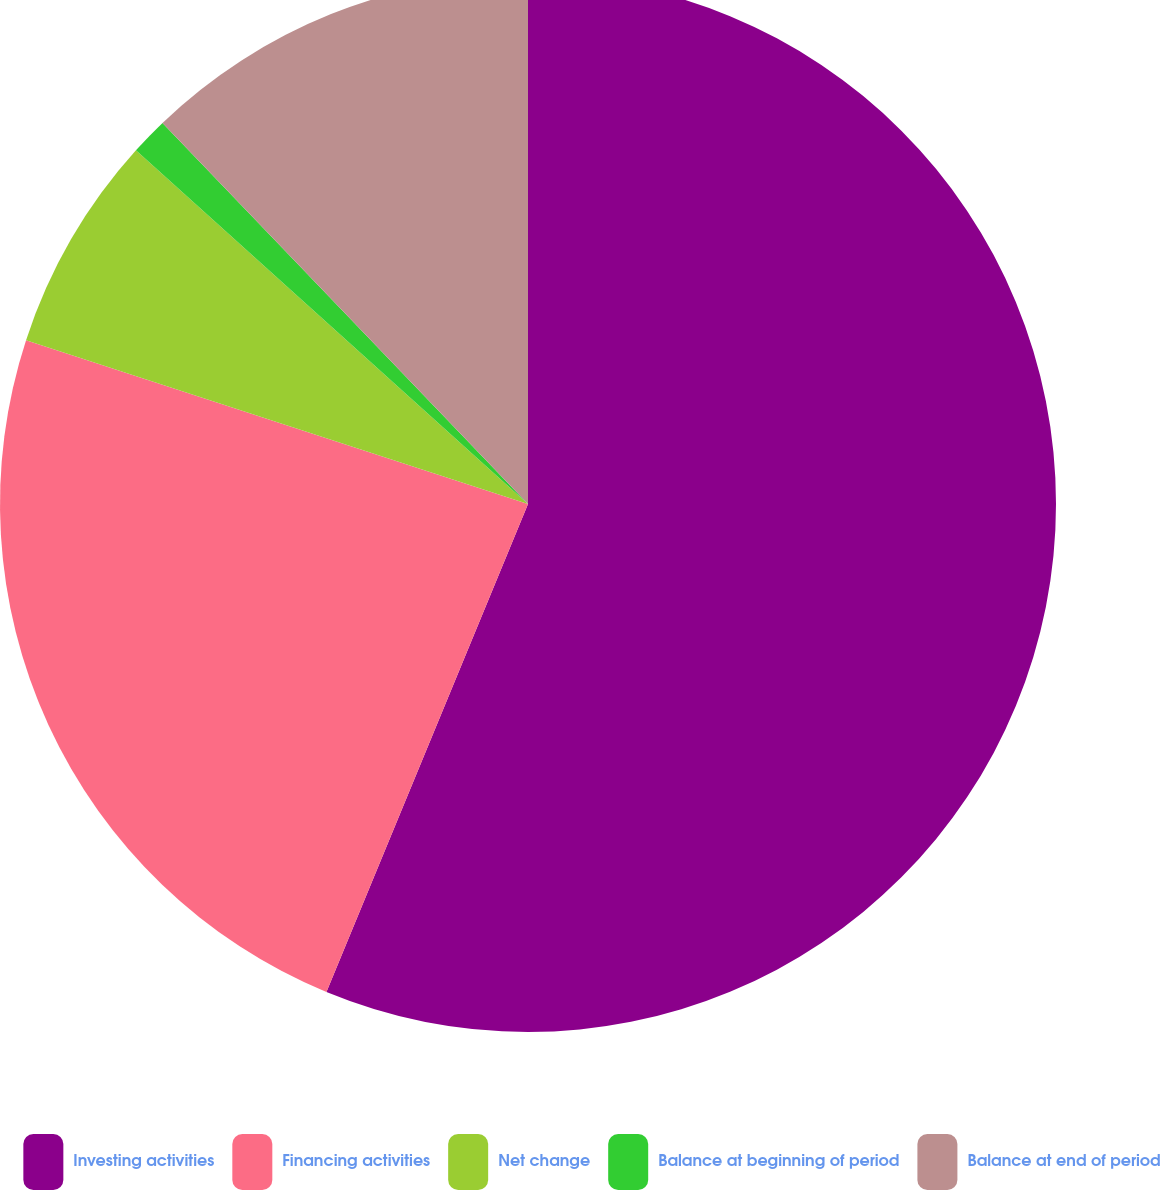Convert chart. <chart><loc_0><loc_0><loc_500><loc_500><pie_chart><fcel>Investing activities<fcel>Financing activities<fcel>Net change<fcel>Balance at beginning of period<fcel>Balance at end of period<nl><fcel>56.24%<fcel>23.79%<fcel>6.66%<fcel>1.15%<fcel>12.17%<nl></chart> 